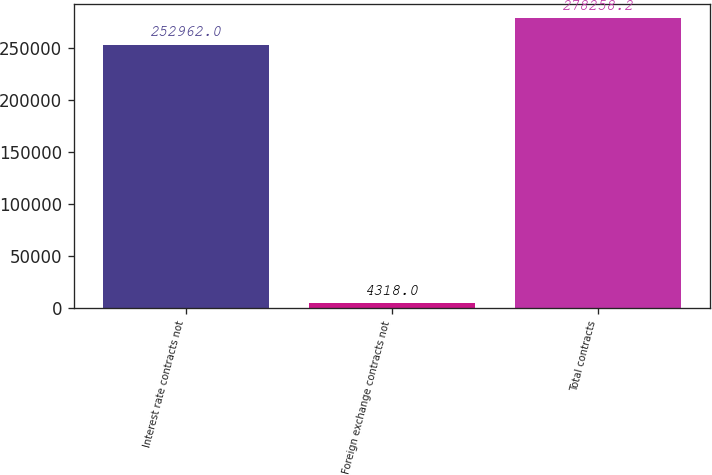Convert chart to OTSL. <chart><loc_0><loc_0><loc_500><loc_500><bar_chart><fcel>Interest rate contracts not<fcel>Foreign exchange contracts not<fcel>Total contracts<nl><fcel>252962<fcel>4318<fcel>278258<nl></chart> 